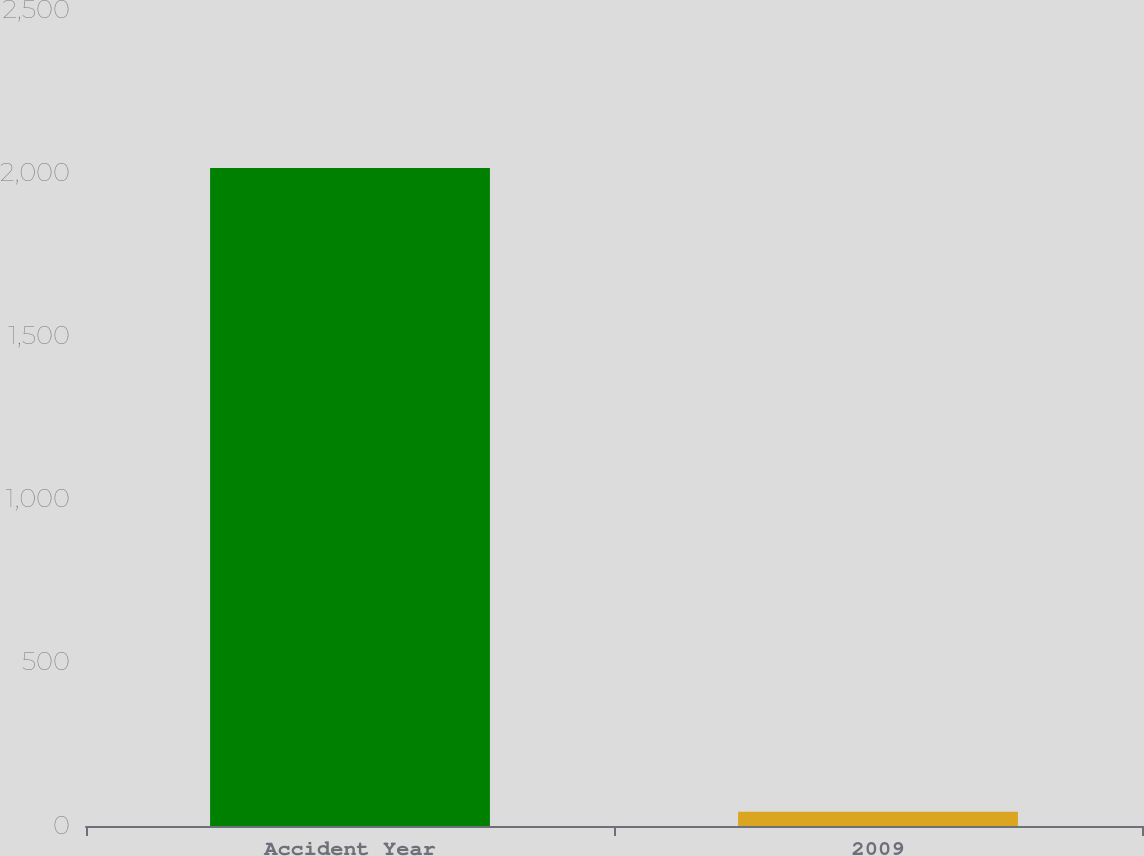Convert chart to OTSL. <chart><loc_0><loc_0><loc_500><loc_500><bar_chart><fcel>Accident Year<fcel>2009<nl><fcel>2016<fcel>44<nl></chart> 